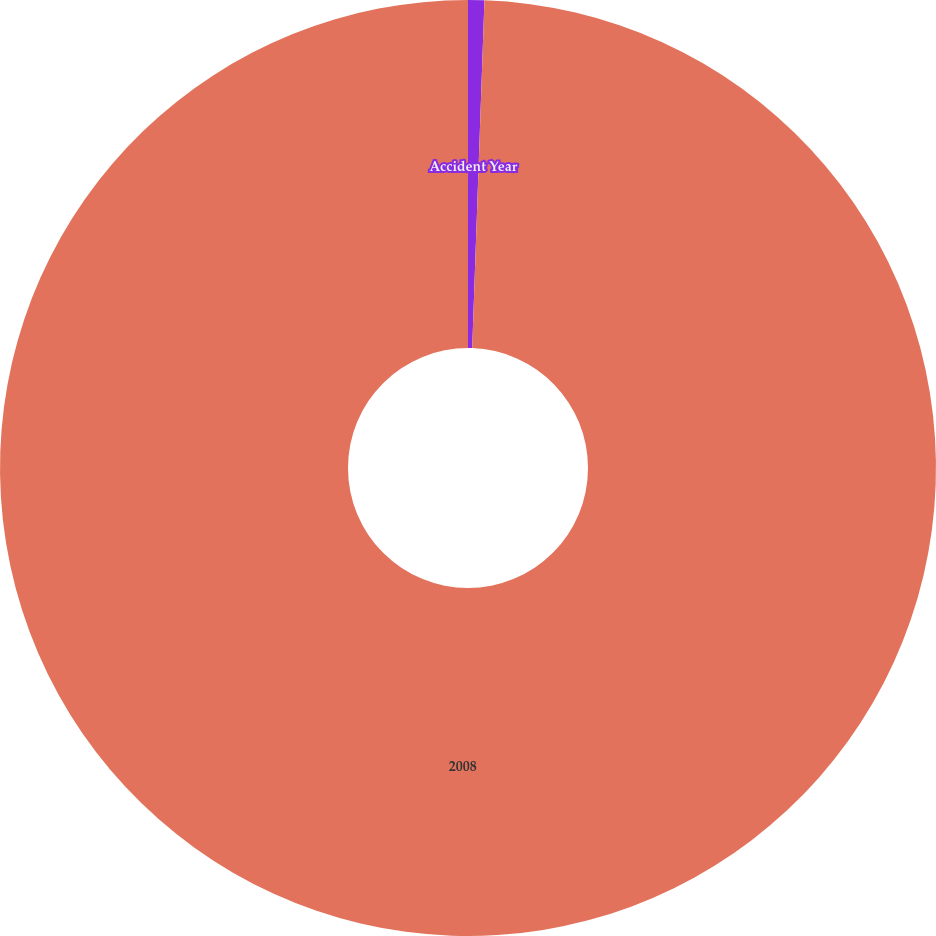Convert chart. <chart><loc_0><loc_0><loc_500><loc_500><pie_chart><fcel>Accident Year<fcel>2008<nl><fcel>0.56%<fcel>99.44%<nl></chart> 